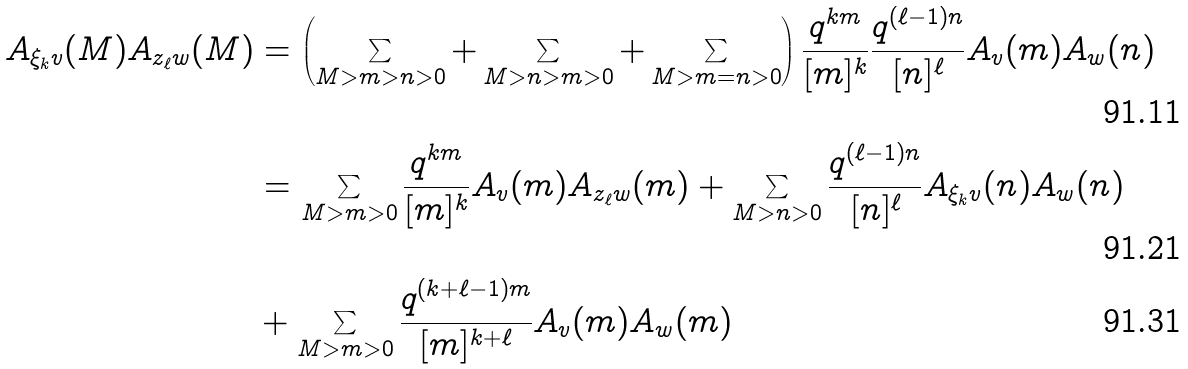<formula> <loc_0><loc_0><loc_500><loc_500>A _ { \xi _ { k } v } ( M ) A _ { z _ { \ell } w } ( M ) & = \left ( \sum _ { M > m > n > 0 } + \sum _ { M > n > m > 0 } + \sum _ { M > m = n > 0 } \right ) \frac { q ^ { k m } } { [ m ] ^ { k } } \frac { q ^ { ( \ell - 1 ) n } } { [ n ] ^ { \ell } } A _ { v } ( m ) A _ { w } ( n ) \\ & = \sum _ { M > m > 0 } \frac { q ^ { k m } } { [ m ] ^ { k } } A _ { v } ( m ) A _ { z _ { \ell } w } ( m ) + \sum _ { M > n > 0 } \frac { q ^ { ( \ell - 1 ) n } } { [ n ] ^ { \ell } } A _ { \xi _ { k } v } ( n ) A _ { w } ( n ) \\ & + \sum _ { M > m > 0 } \frac { q ^ { ( k + \ell - 1 ) m } } { [ m ] ^ { k + \ell } } A _ { v } ( m ) A _ { w } ( m )</formula> 